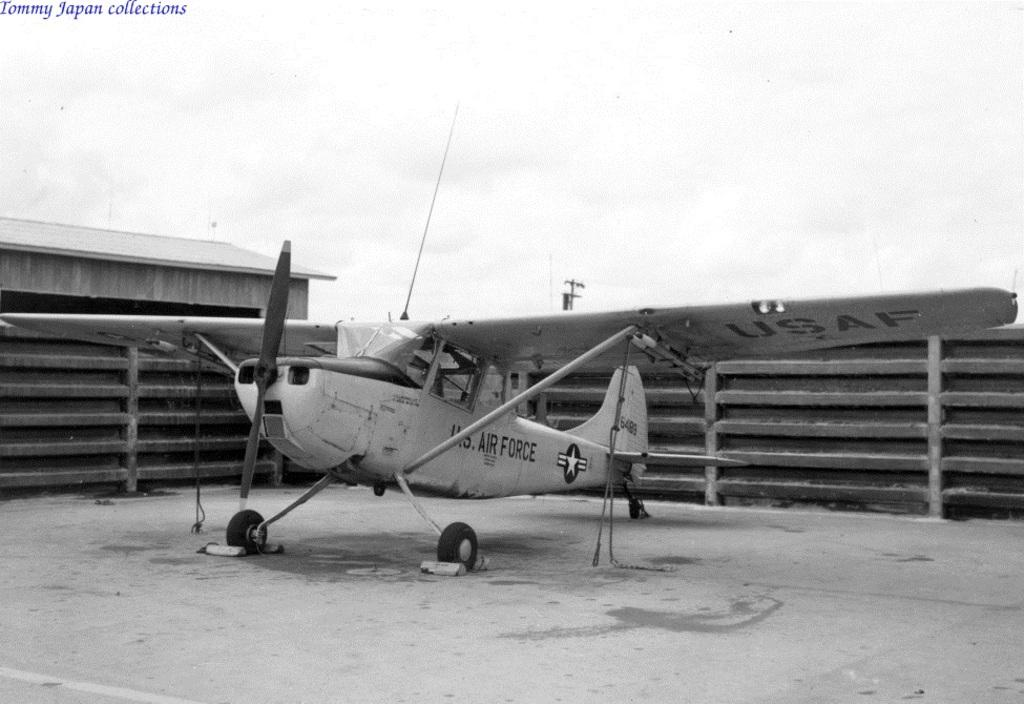Provide a one-sentence caption for the provided image. a Tommy Japan Collections US Airforce old airplane. 